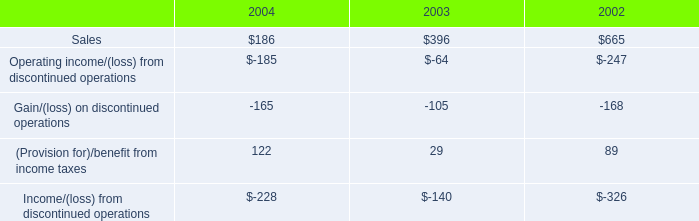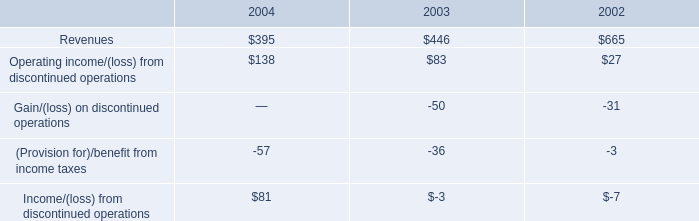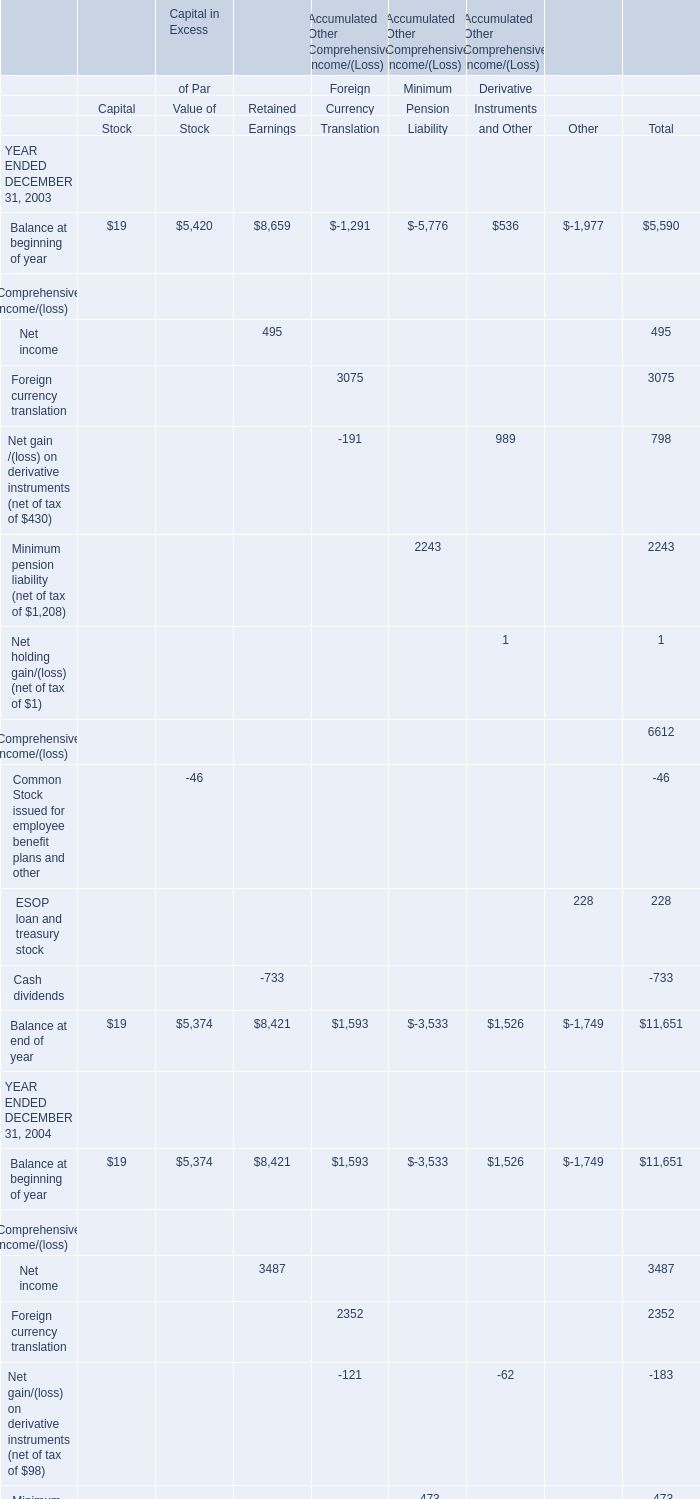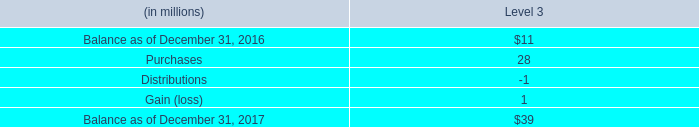Balance at beginning of which year ENDED DECEMBER 31 in terms of Retained Earnings is the highest? 
Answer: 2005. 